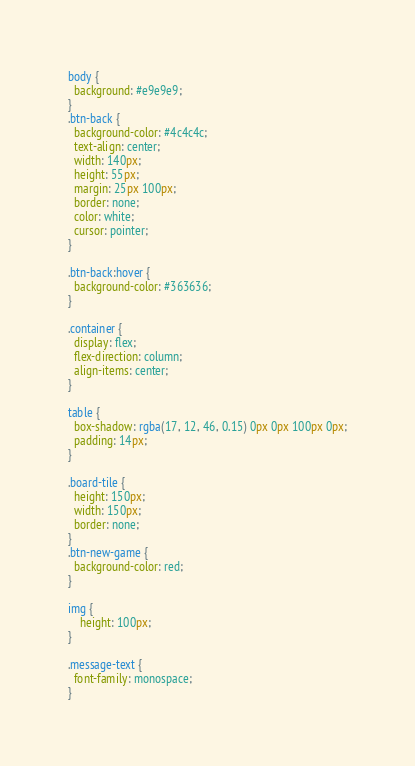Convert code to text. <code><loc_0><loc_0><loc_500><loc_500><_CSS_>body {
  background: #e9e9e9;
}
.btn-back {
  background-color: #4c4c4c;
  text-align: center;
  width: 140px;
  height: 55px;
  margin: 25px 100px;
  border: none;
  color: white;
  cursor: pointer;
}

.btn-back:hover {
  background-color: #363636;
}

.container {
  display: flex;
  flex-direction: column;
  align-items: center;
}

table {
  box-shadow: rgba(17, 12, 46, 0.15) 0px 0px 100px 0px;
  padding: 14px;
}

.board-tile {
  height: 150px;
  width: 150px;
  border: none;
}
.btn-new-game {
  background-color: red;
}

img {
	height: 100px;
}

.message-text {
  font-family: monospace;
}</code> 